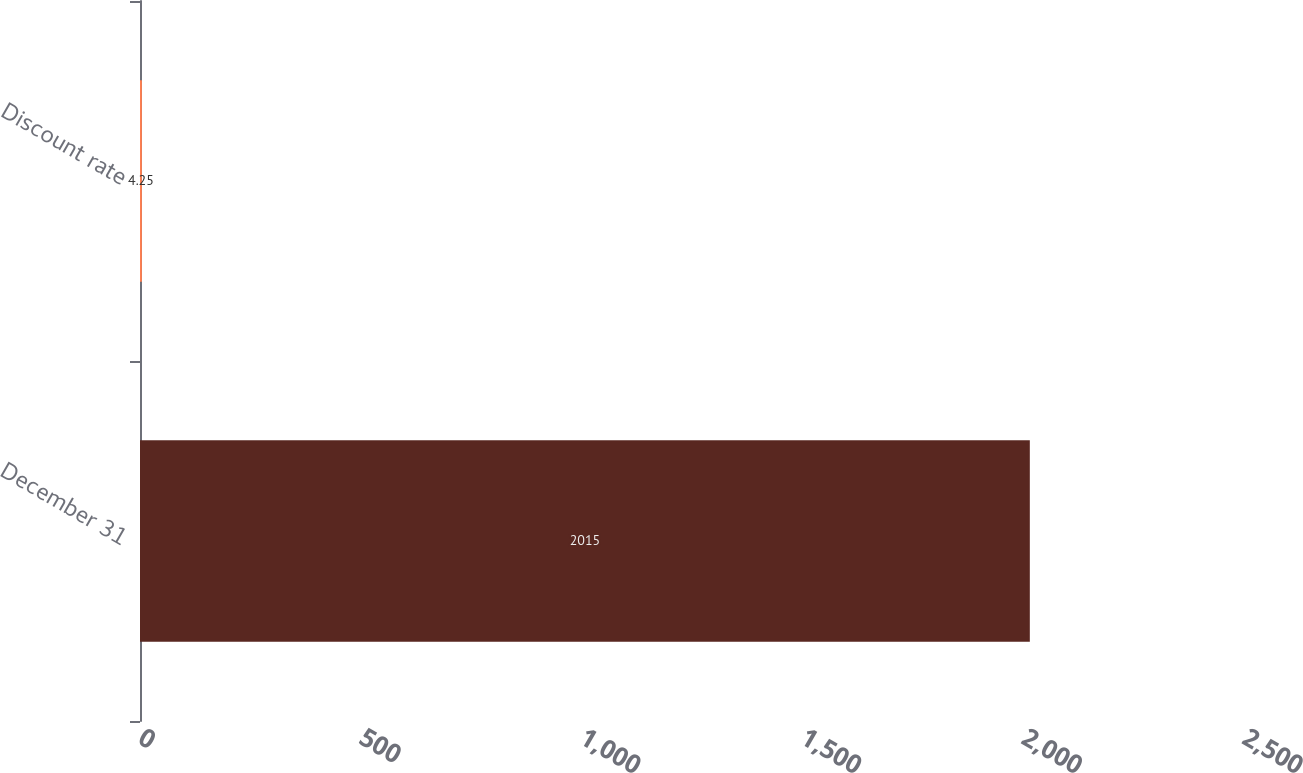Convert chart to OTSL. <chart><loc_0><loc_0><loc_500><loc_500><bar_chart><fcel>December 31<fcel>Discount rate<nl><fcel>2015<fcel>4.25<nl></chart> 